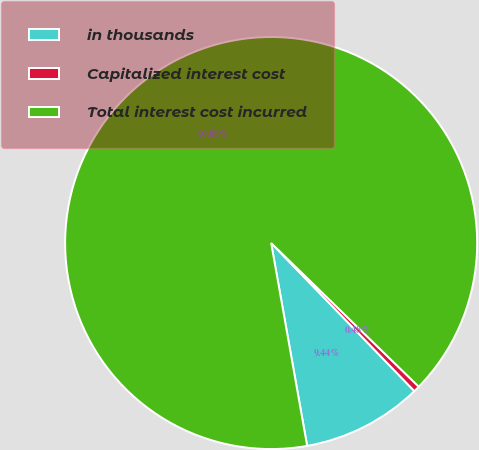<chart> <loc_0><loc_0><loc_500><loc_500><pie_chart><fcel>in thousands<fcel>Capitalized interest cost<fcel>Total interest cost incurred<nl><fcel>9.44%<fcel>0.48%<fcel>90.08%<nl></chart> 